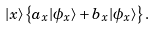Convert formula to latex. <formula><loc_0><loc_0><loc_500><loc_500>| x \rangle \left \{ a _ { x } | \phi _ { x } \rangle + b _ { x } | \phi _ { x } \rangle \right \} .</formula> 